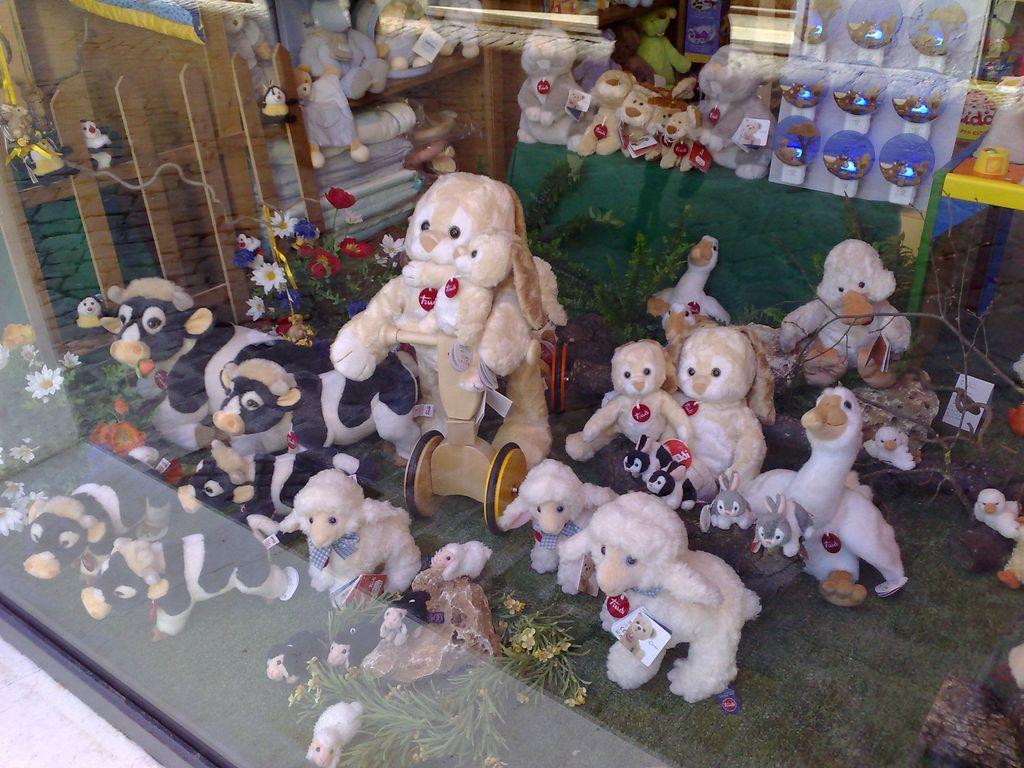Describe this image in one or two sentences. In this picture I can see there are few soft toys of rabbits, cows, sheep and ducks. 